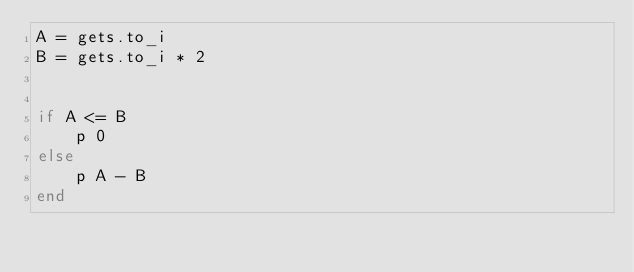Convert code to text. <code><loc_0><loc_0><loc_500><loc_500><_Ruby_>A = gets.to_i
B = gets.to_i * 2 


if A <= B
    p 0 
else 
    p A - B
end</code> 